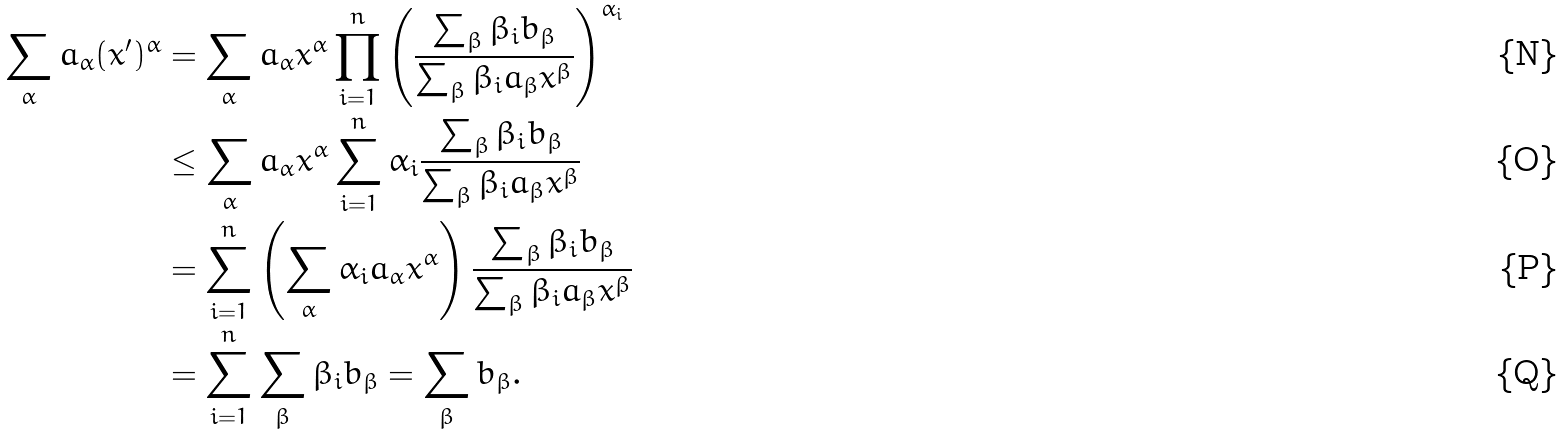Convert formula to latex. <formula><loc_0><loc_0><loc_500><loc_500>\sum _ { \alpha } a _ { \alpha } ( x ^ { \prime } ) ^ { \alpha } & = \sum _ { \alpha } a _ { \alpha } x ^ { \alpha } \prod _ { i = 1 } ^ { n } \left ( \frac { \sum _ { \beta } \beta _ { i } b _ { \beta } } { \sum _ { \beta } \beta _ { i } a _ { \beta } x ^ { \beta } } \right ) ^ { \alpha _ { i } } \\ & \leq \sum _ { \alpha } a _ { \alpha } x ^ { \alpha } \sum _ { i = 1 } ^ { n } \alpha _ { i } \frac { \sum _ { \beta } \beta _ { i } b _ { \beta } } { \sum _ { \beta } \beta _ { i } a _ { \beta } x ^ { \beta } } \\ & = \sum _ { i = 1 } ^ { n } \left ( \sum _ { \alpha } \alpha _ { i } a _ { \alpha } x ^ { \alpha } \right ) \frac { \sum _ { \beta } \beta _ { i } b _ { \beta } } { \sum _ { \beta } \beta _ { i } a _ { \beta } x ^ { \beta } } \\ & = \sum _ { i = 1 } ^ { n } \sum _ { \beta } \beta _ { i } b _ { \beta } = \sum _ { \beta } b _ { \beta } .</formula> 